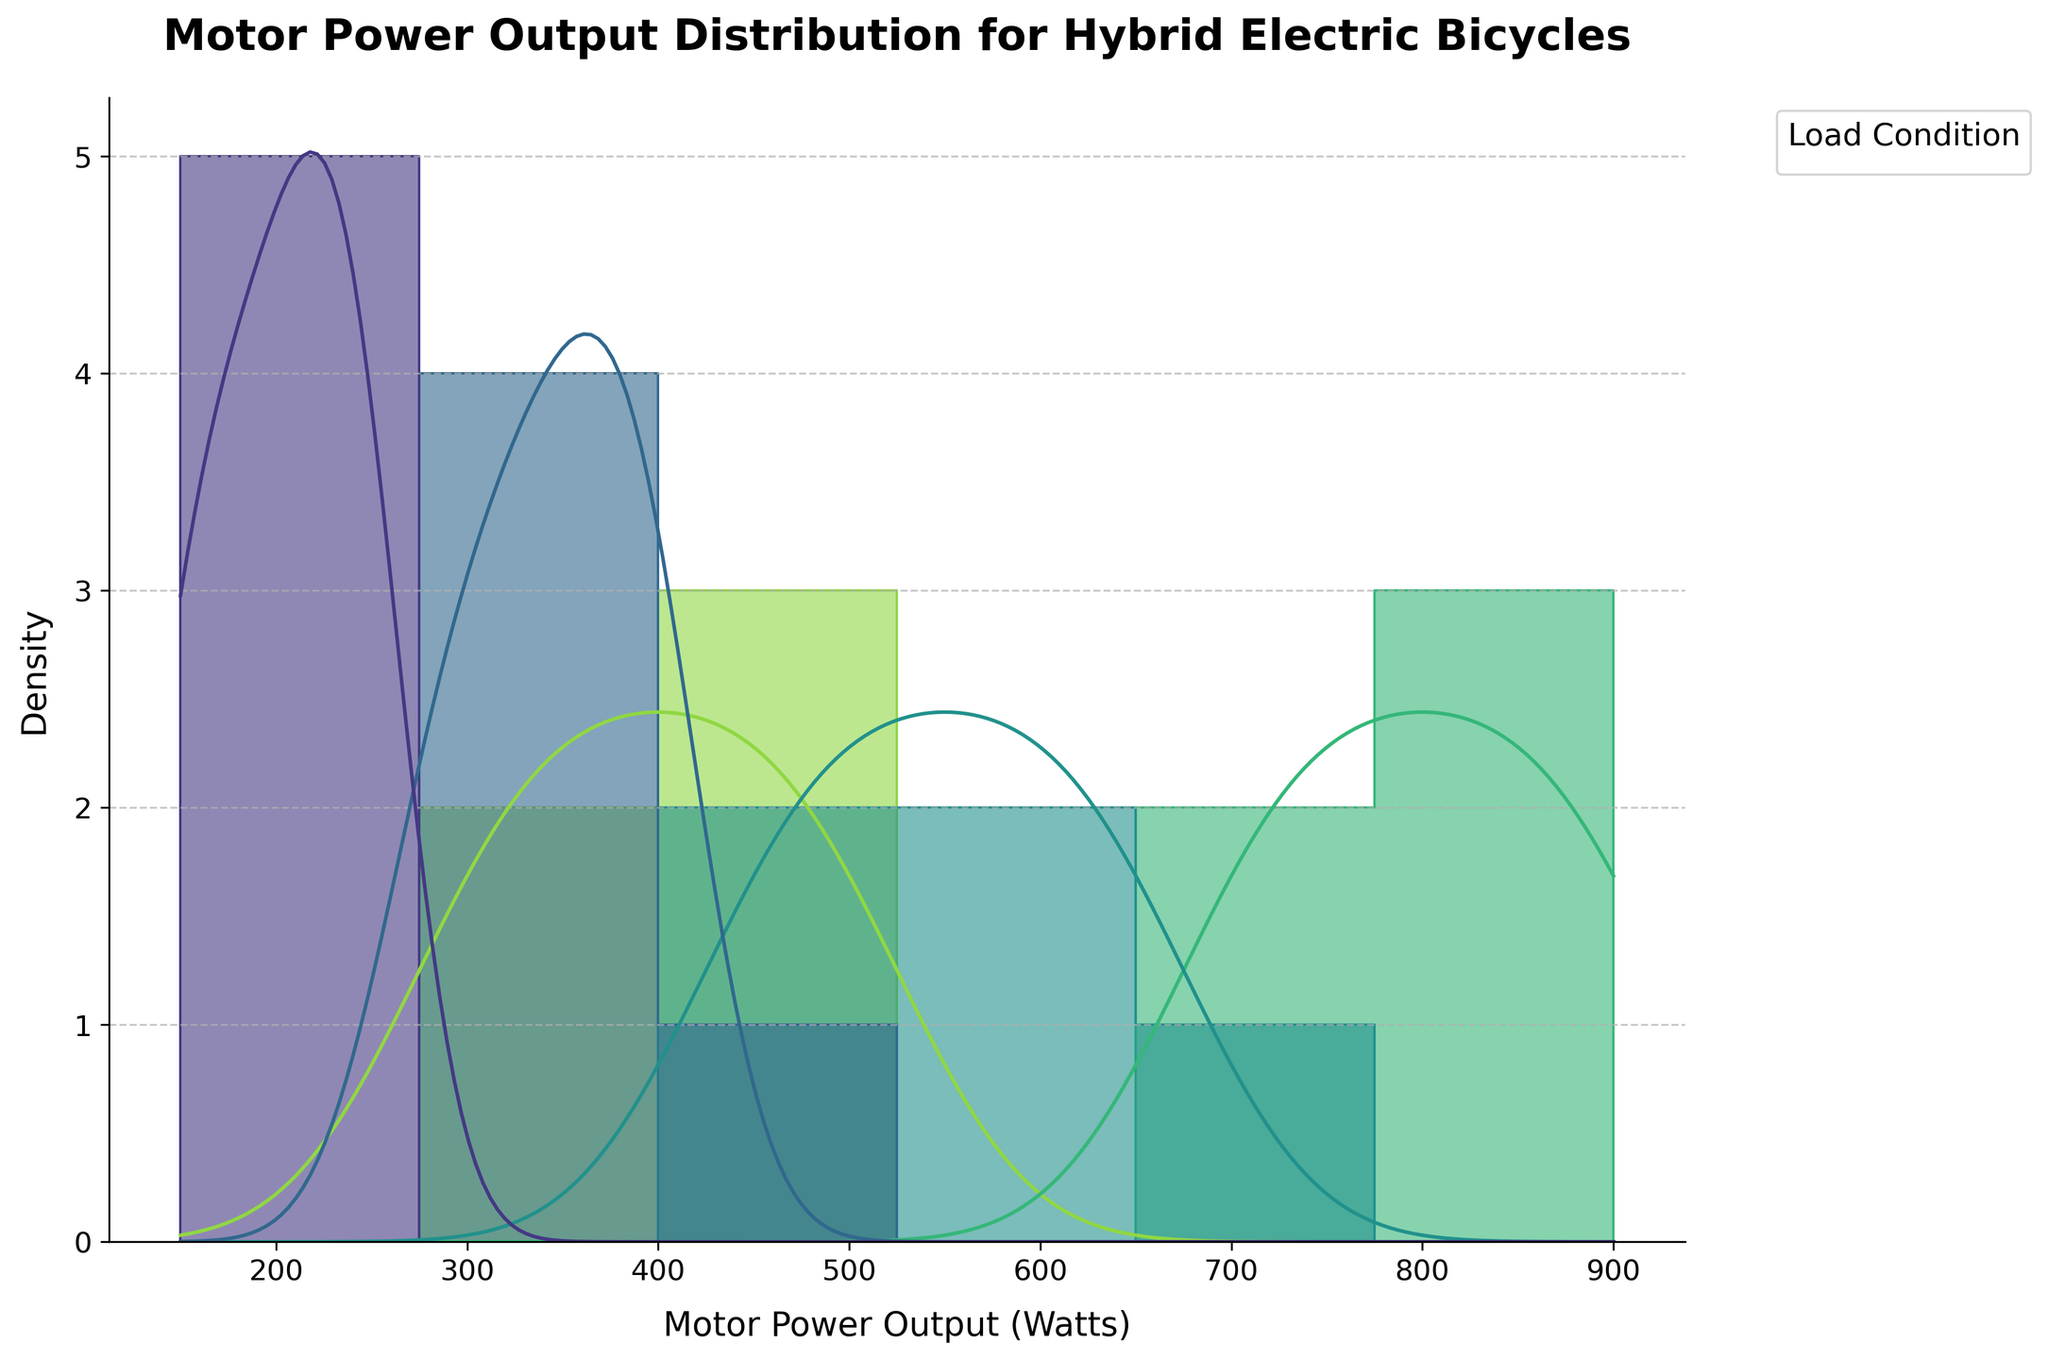What is the title of the histogram? The title of the histogram is prominently displayed at the top of the figure.
Answer: Motor Power Output Distribution for Hybrid Electric Bicycles What load condition has the highest motor power output? By examining the KDE curves and histograms, you can see which load condition extends to the highest motor power output value.
Answer: Steep Hill How does the motor power output for a moderate hill compare to a flat road? Compare the KDE curves for "Moderate Hill" and "Flat Road". Notice that "Moderate Hill" has a higher range of power outputs compared to "Flat Road".
Answer: Higher What is the general shape of the KDE curve for the "Headwind" load condition? Look at the density plot line for the "Headwind" load condition to determine its shape.
Answer: Bimodal Which load condition has the lowest range of motor power output? Compare the width of the KDE curves for all load conditions. The load condition with the narrowest width has the lowest range.
Answer: Flat Road At what motor power output value do all load conditions start to overlap? Observing where all KDE curves begin to converge will provide this value.
Answer: Around 300 Watts What is the highest density value for the "Slight Incline" load condition? Examine the peak height of the KDE curve for the "Slight Incline" load condition, as this represents the highest density value.
Answer: Between 350-400 Watts How does the density of motor power output change as the load condition becomes steeper? Sequentially compare the KDE curves from "Flat Road" to "Steep Hill". The KDE curves shift and change in density indicating the variation.
Answer: Density increases Which load condition has the most evenly distributed motor power output? Assess the overall shape and spread of the KDE curves; the one with the flattest and broadest shape will have the most even distribution.
Answer: Steep Hill What is the range of motor power outputs for the "Steep Hill" condition? Look at the histogram and KDE curve for the "Steep Hill" load condition to determine the minimum and maximum values.
Answer: 700-900 Watts 